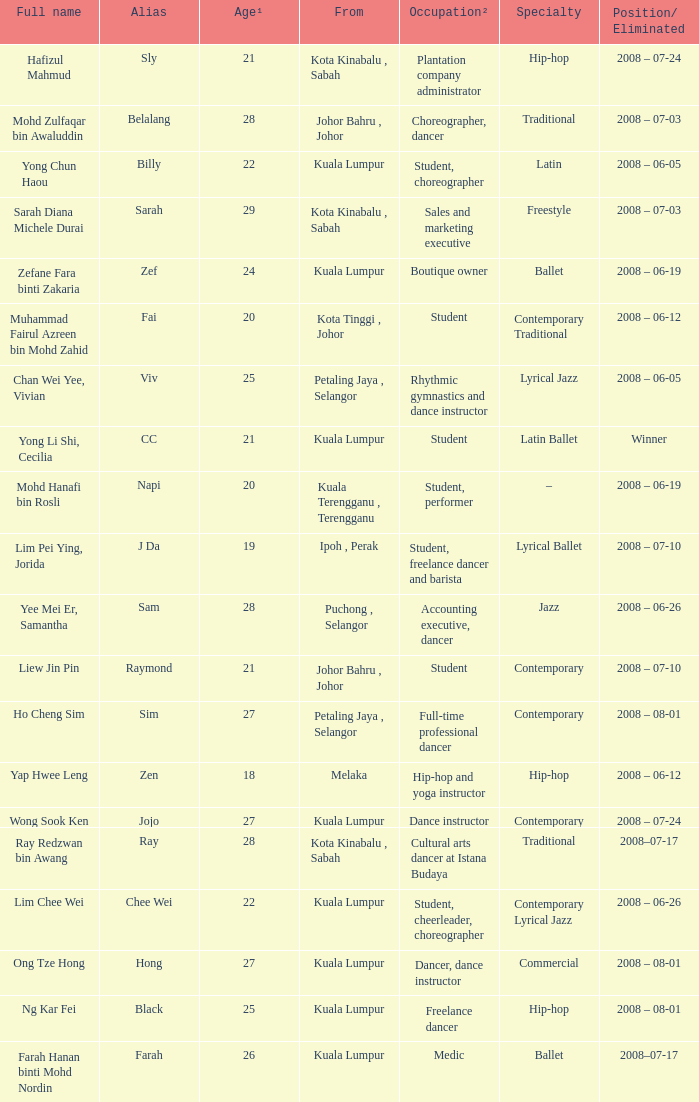What is Position/ Eliminated, when Age¹ is less than 22, and when Full Name is "Muhammad Fairul Azreen Bin Mohd Zahid"? 2008 – 06-12. 